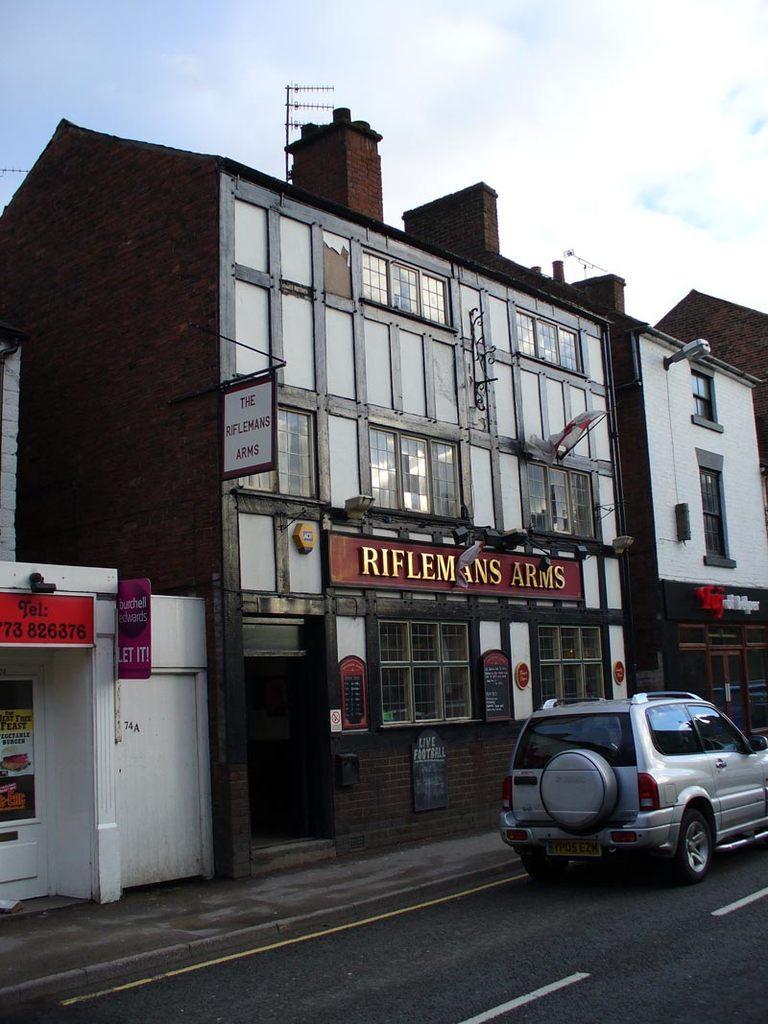Could you give a brief overview of what you see in this image? In this image in the center there are some buildings, and there is one vehicle. At the bottom there is road, on the buildings there is some text and also we could see some lights and some boards. On the boards there is text and at the top of the building there are some antennas, at the top there is sky. 